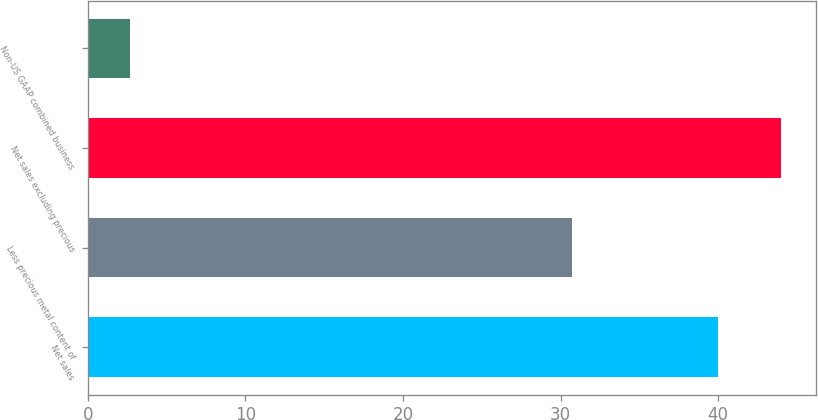Convert chart to OTSL. <chart><loc_0><loc_0><loc_500><loc_500><bar_chart><fcel>Net sales<fcel>Less precious metal content of<fcel>Net sales excluding precious<fcel>Non-US GAAP combined business<nl><fcel>40<fcel>30.7<fcel>43.99<fcel>2.7<nl></chart> 